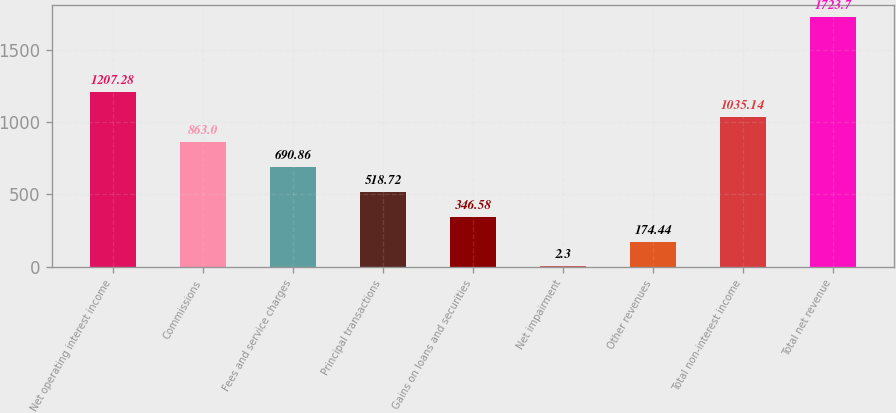<chart> <loc_0><loc_0><loc_500><loc_500><bar_chart><fcel>Net operating interest income<fcel>Commissions<fcel>Fees and service charges<fcel>Principal transactions<fcel>Gains on loans and securities<fcel>Net impairment<fcel>Other revenues<fcel>Total non-interest income<fcel>Total net revenue<nl><fcel>1207.28<fcel>863<fcel>690.86<fcel>518.72<fcel>346.58<fcel>2.3<fcel>174.44<fcel>1035.14<fcel>1723.7<nl></chart> 